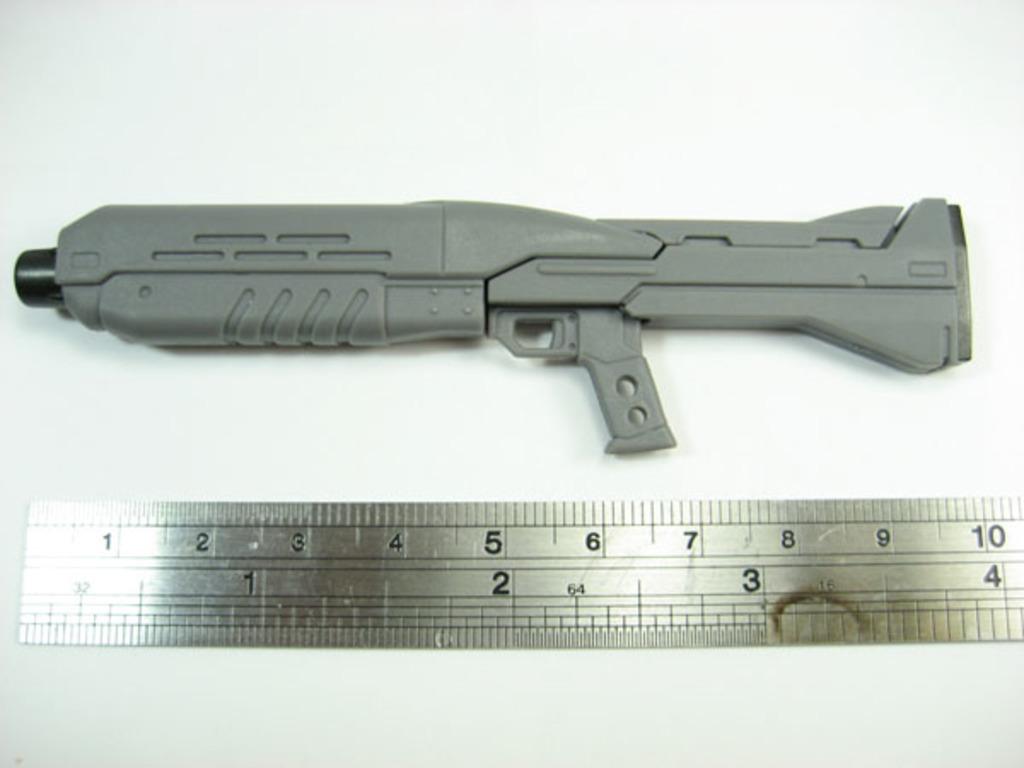How long is this gun?
Provide a short and direct response. 10. What is the highest number on the ruler?
Offer a terse response. 10. 